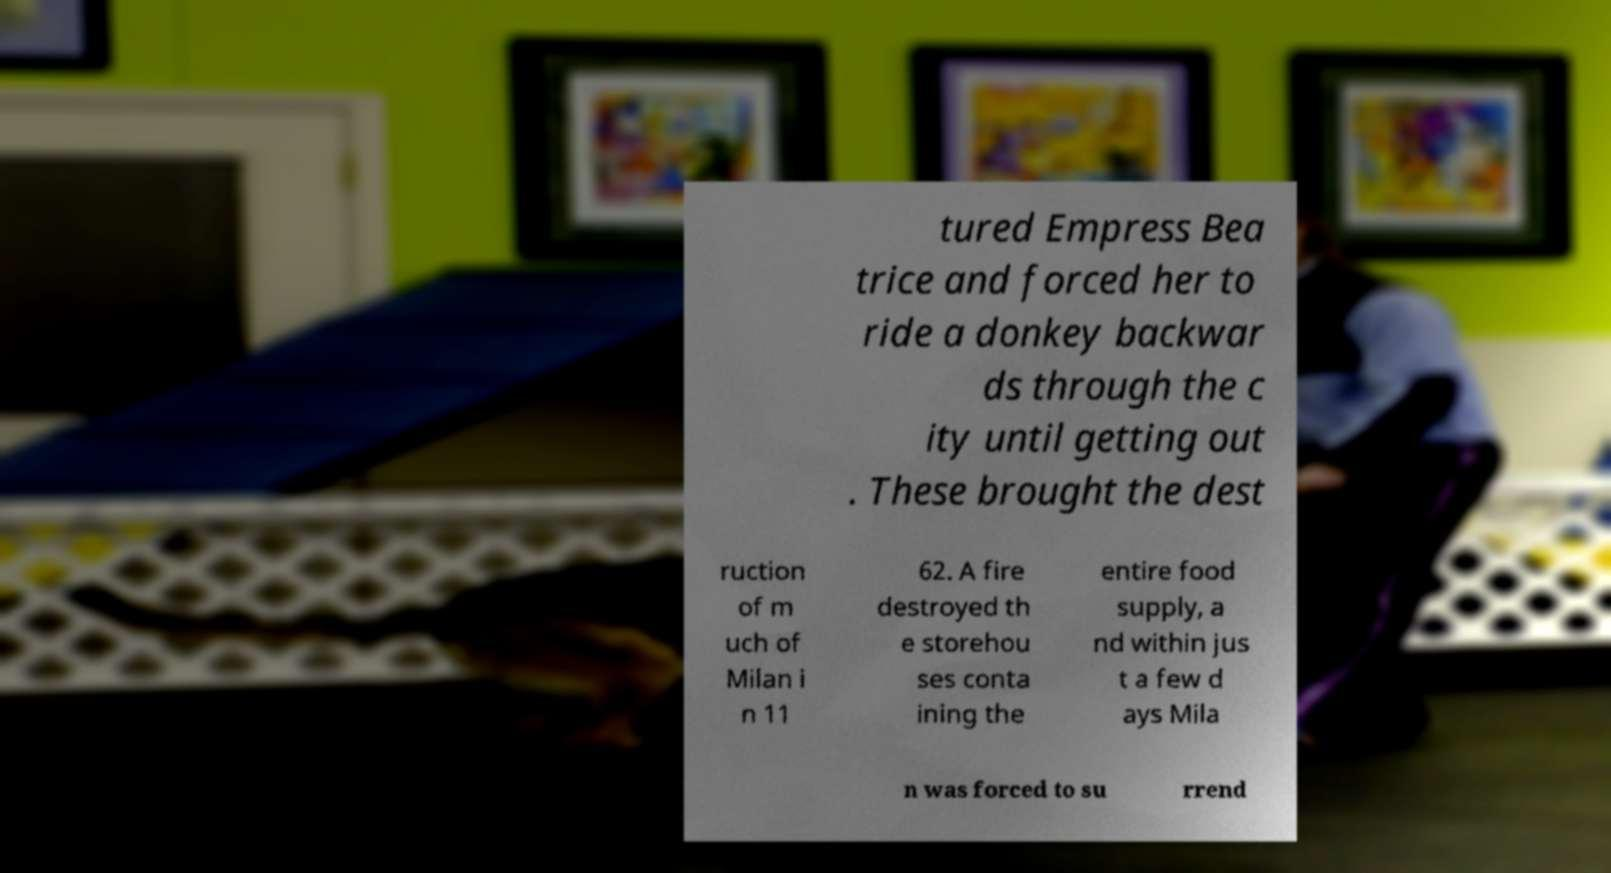Could you extract and type out the text from this image? tured Empress Bea trice and forced her to ride a donkey backwar ds through the c ity until getting out . These brought the dest ruction of m uch of Milan i n 11 62. A fire destroyed th e storehou ses conta ining the entire food supply, a nd within jus t a few d ays Mila n was forced to su rrend 